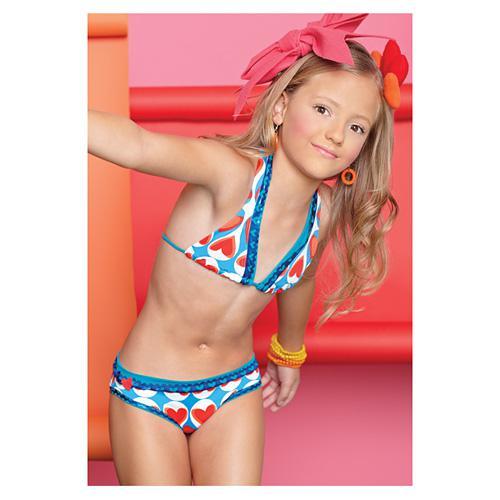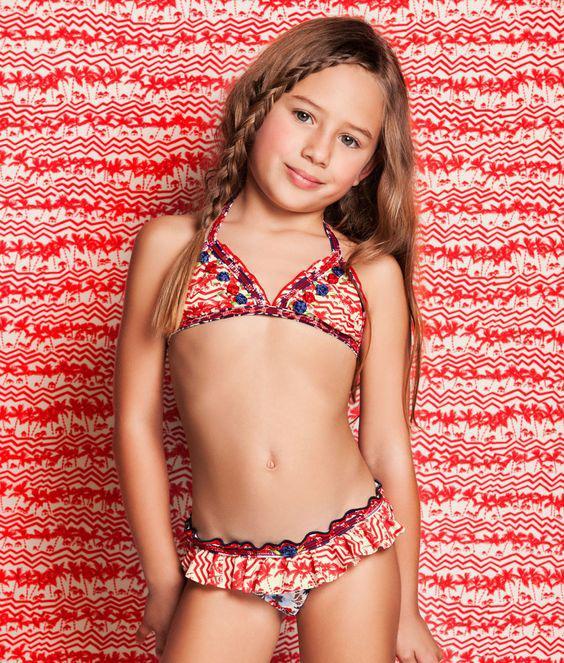The first image is the image on the left, the second image is the image on the right. Given the left and right images, does the statement "A girl is laying down in colorful hearts" hold true? Answer yes or no. No. 